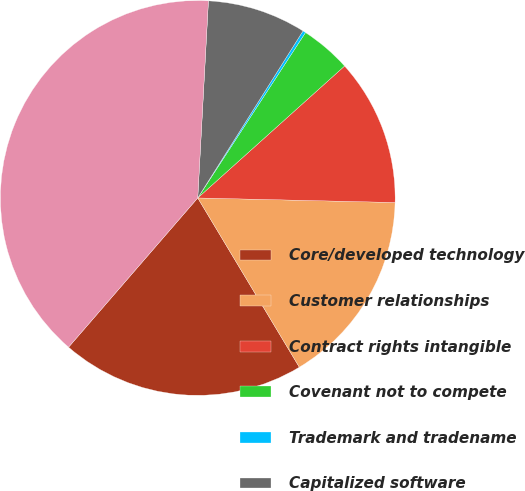Convert chart. <chart><loc_0><loc_0><loc_500><loc_500><pie_chart><fcel>Core/developed technology<fcel>Customer relationships<fcel>Contract rights intangible<fcel>Covenant not to compete<fcel>Trademark and tradename<fcel>Capitalized software<fcel>Total<nl><fcel>19.96%<fcel>16.03%<fcel>12.02%<fcel>4.16%<fcel>0.24%<fcel>8.09%<fcel>39.51%<nl></chart> 